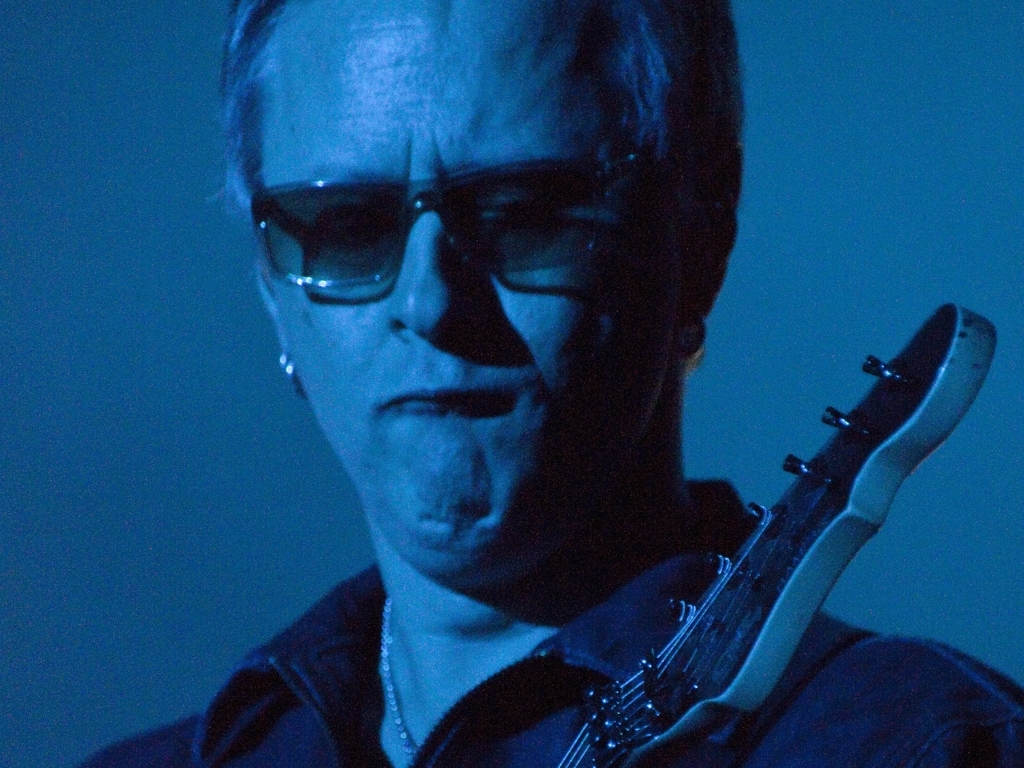Why is the overall image considered poor in quality? The image is considered poor in quality due to its blur and lack of clarity, which obscures fine details in the scene. In addition to the blur, the color selection does not seem optimal, with a monochromatic blue tint dominating the image, which may not accurately represent the subject's natural colors. The texture details are difficult to discern, contributing to an overall lackluster visual experience that falls short of what would be expected from a high-quality photograph. 